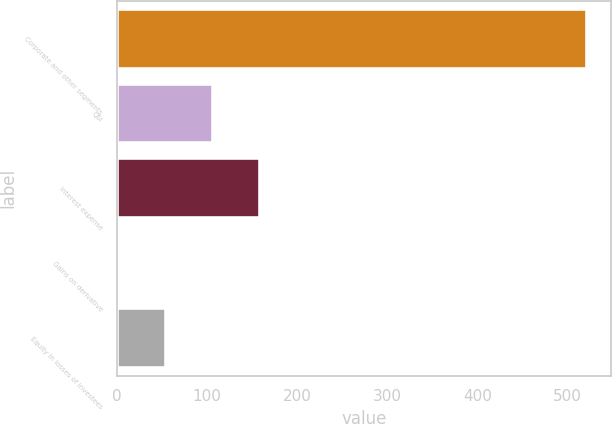Convert chart. <chart><loc_0><loc_0><loc_500><loc_500><bar_chart><fcel>Corporate and other segments<fcel>QSI<fcel>Interest expense<fcel>Gains on derivative<fcel>Equity in losses of investees<nl><fcel>522<fcel>106.8<fcel>158.7<fcel>3<fcel>54.9<nl></chart> 